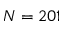Convert formula to latex. <formula><loc_0><loc_0><loc_500><loc_500>N = 2 0 1</formula> 